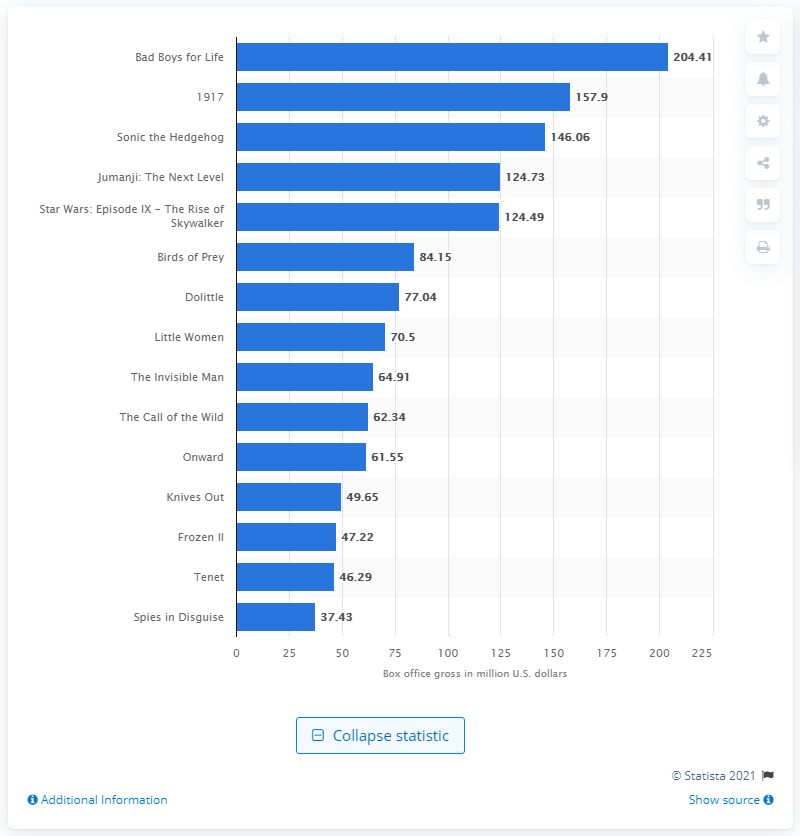Highlight a few significant elements in this photo. The domestic box office revenue of Bad Boys for Life was approximately 204.41 million. According to the reported earnings, the movies '1917' and 'Sonic The Hedgehog' grossed a total of 204.41 million dollars. 